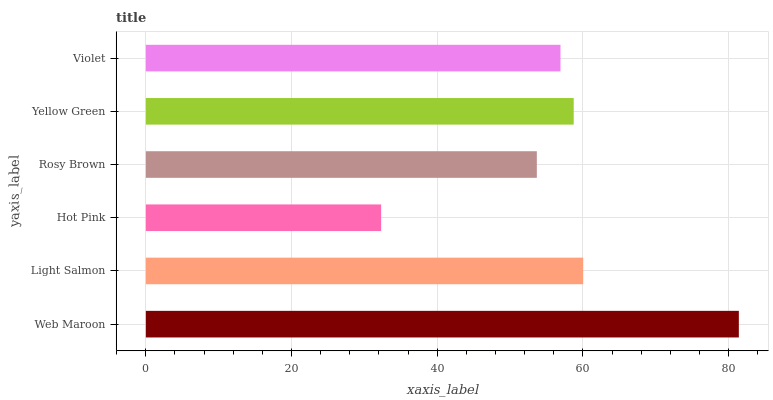Is Hot Pink the minimum?
Answer yes or no. Yes. Is Web Maroon the maximum?
Answer yes or no. Yes. Is Light Salmon the minimum?
Answer yes or no. No. Is Light Salmon the maximum?
Answer yes or no. No. Is Web Maroon greater than Light Salmon?
Answer yes or no. Yes. Is Light Salmon less than Web Maroon?
Answer yes or no. Yes. Is Light Salmon greater than Web Maroon?
Answer yes or no. No. Is Web Maroon less than Light Salmon?
Answer yes or no. No. Is Yellow Green the high median?
Answer yes or no. Yes. Is Violet the low median?
Answer yes or no. Yes. Is Light Salmon the high median?
Answer yes or no. No. Is Yellow Green the low median?
Answer yes or no. No. 